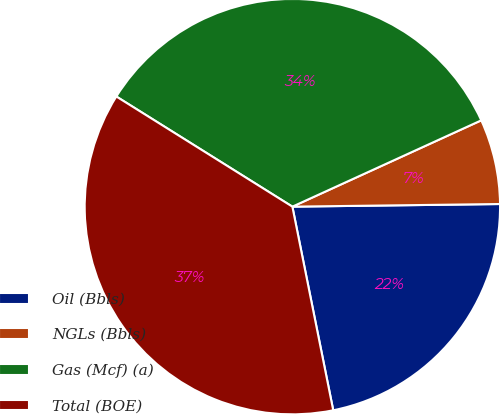<chart> <loc_0><loc_0><loc_500><loc_500><pie_chart><fcel>Oil (Bbls)<fcel>NGLs (Bbls)<fcel>Gas (Mcf) (a)<fcel>Total (BOE)<nl><fcel>22.05%<fcel>6.62%<fcel>34.28%<fcel>37.05%<nl></chart> 